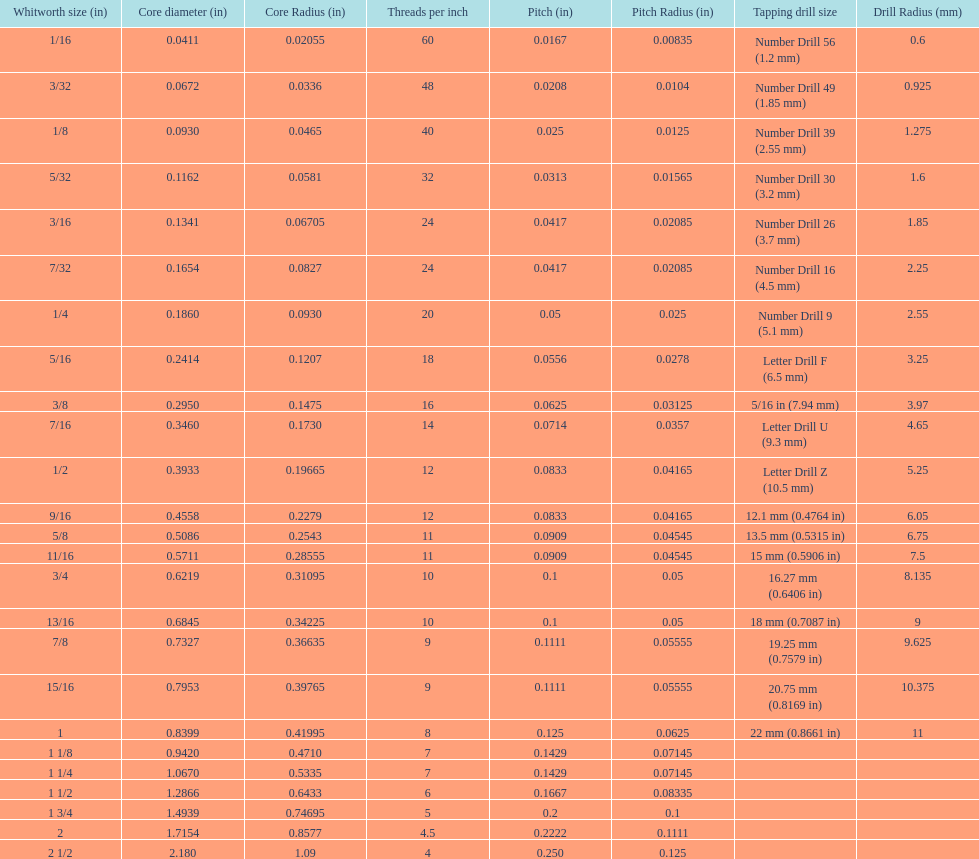What is the core diameter of the first 1/8 whitworth size (in)? 0.0930. 